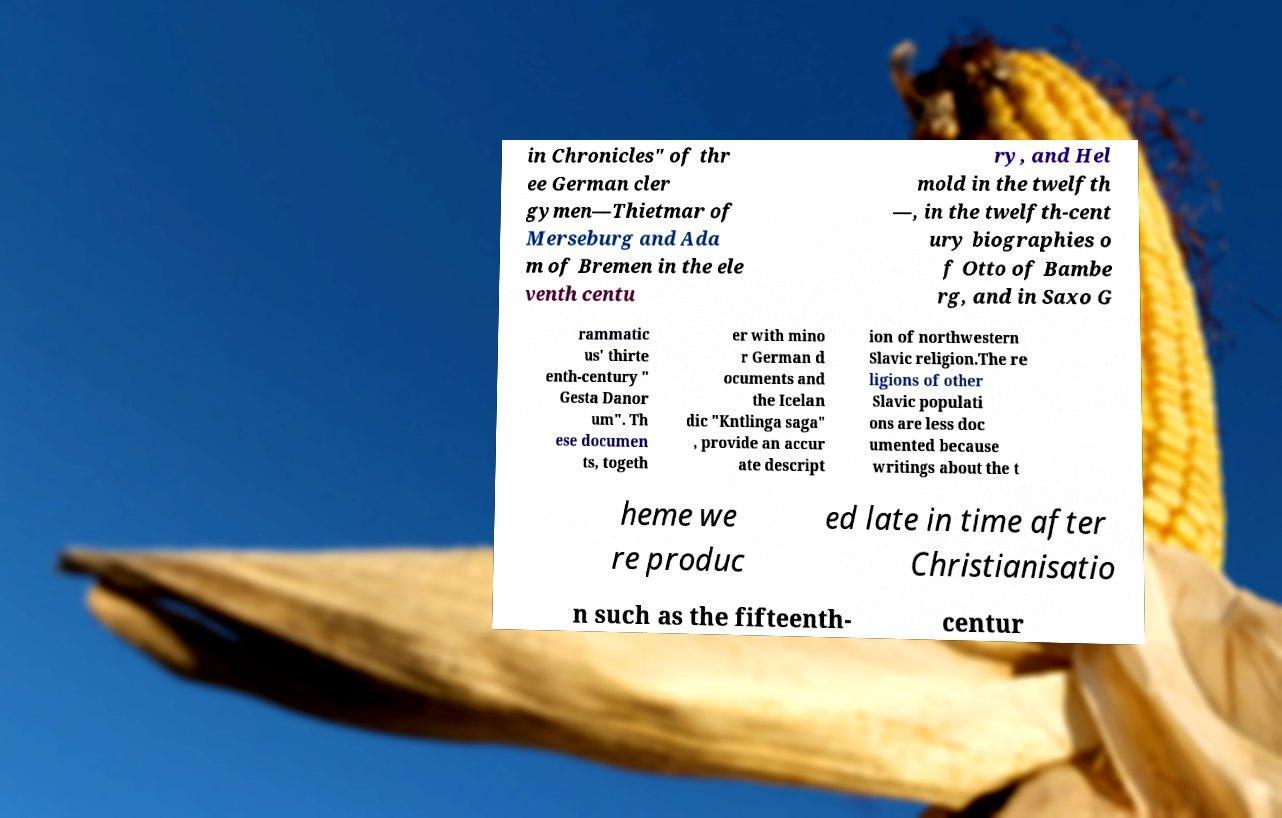Please identify and transcribe the text found in this image. in Chronicles" of thr ee German cler gymen—Thietmar of Merseburg and Ada m of Bremen in the ele venth centu ry, and Hel mold in the twelfth —, in the twelfth-cent ury biographies o f Otto of Bambe rg, and in Saxo G rammatic us' thirte enth-century " Gesta Danor um". Th ese documen ts, togeth er with mino r German d ocuments and the Icelan dic "Kntlinga saga" , provide an accur ate descript ion of northwestern Slavic religion.The re ligions of other Slavic populati ons are less doc umented because writings about the t heme we re produc ed late in time after Christianisatio n such as the fifteenth- centur 